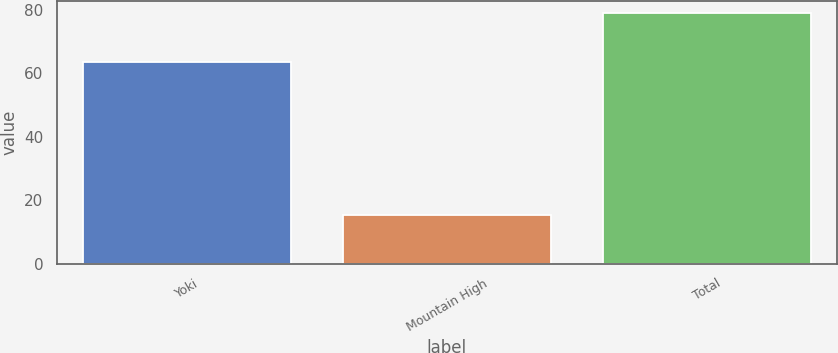<chart> <loc_0><loc_0><loc_500><loc_500><bar_chart><fcel>Yoki<fcel>Mountain High<fcel>Total<nl><fcel>63.6<fcel>15.4<fcel>79<nl></chart> 